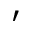<formula> <loc_0><loc_0><loc_500><loc_500>^ { \prime }</formula> 